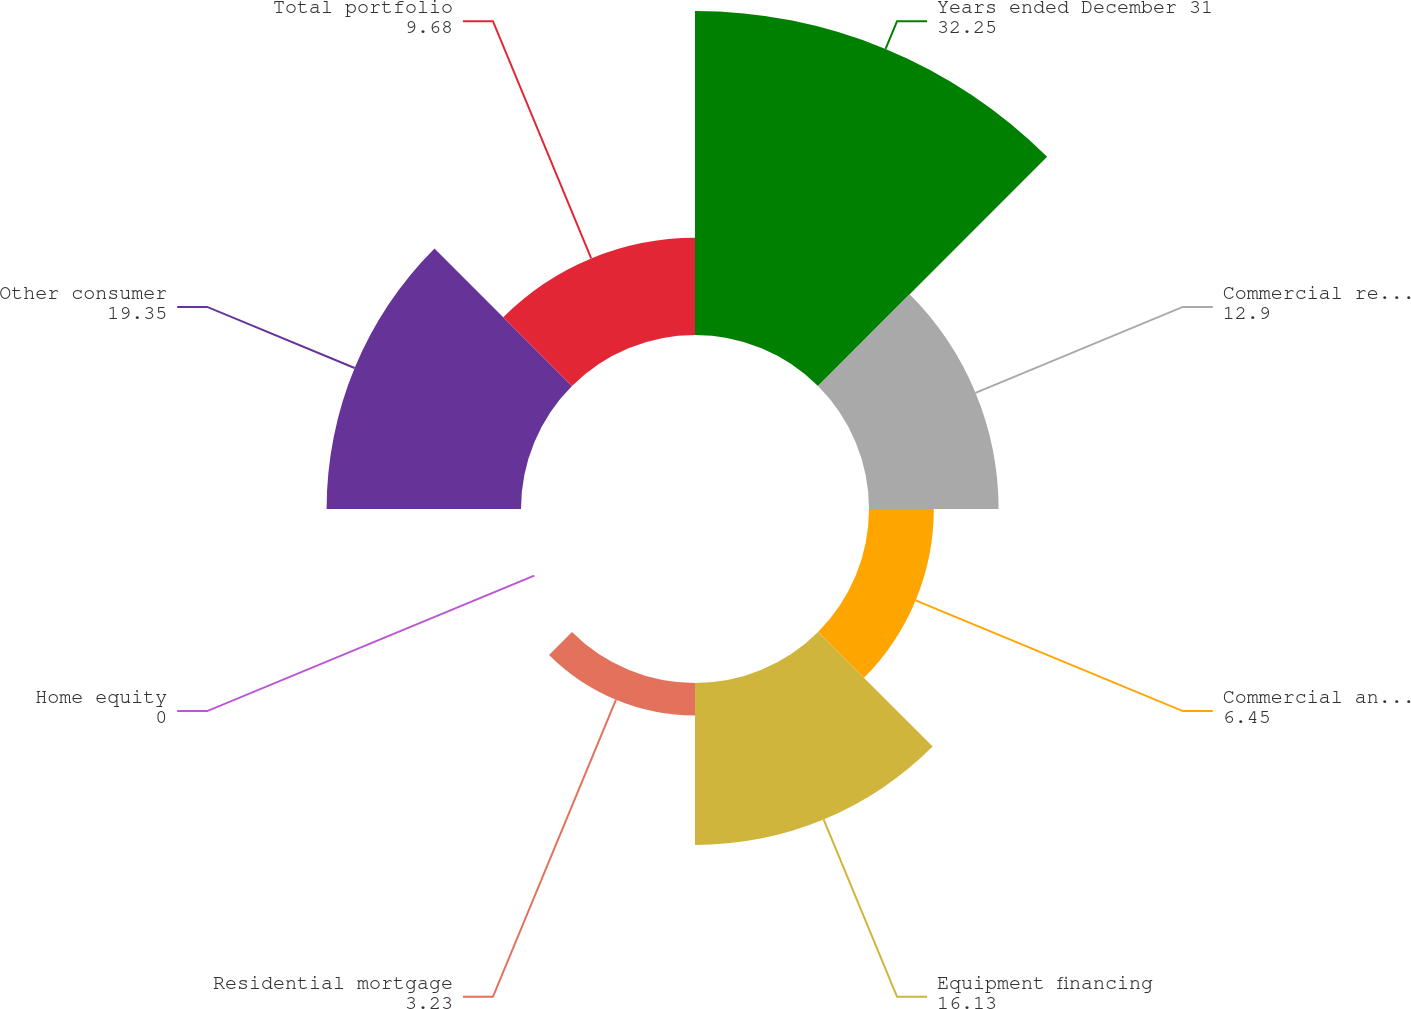Convert chart to OTSL. <chart><loc_0><loc_0><loc_500><loc_500><pie_chart><fcel>Years ended December 31<fcel>Commercial real estate<fcel>Commercial and industrial<fcel>Equipment financing<fcel>Residential mortgage<fcel>Home equity<fcel>Other consumer<fcel>Total portfolio<nl><fcel>32.25%<fcel>12.9%<fcel>6.45%<fcel>16.13%<fcel>3.23%<fcel>0.0%<fcel>19.35%<fcel>9.68%<nl></chart> 